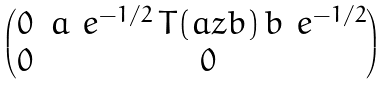<formula> <loc_0><loc_0><loc_500><loc_500>\begin{pmatrix} 0 & a _ { \ } e ^ { - 1 / 2 } \, T ( a z b ) \, b _ { \ } e ^ { - 1 / 2 } \\ 0 & 0 \end{pmatrix}</formula> 